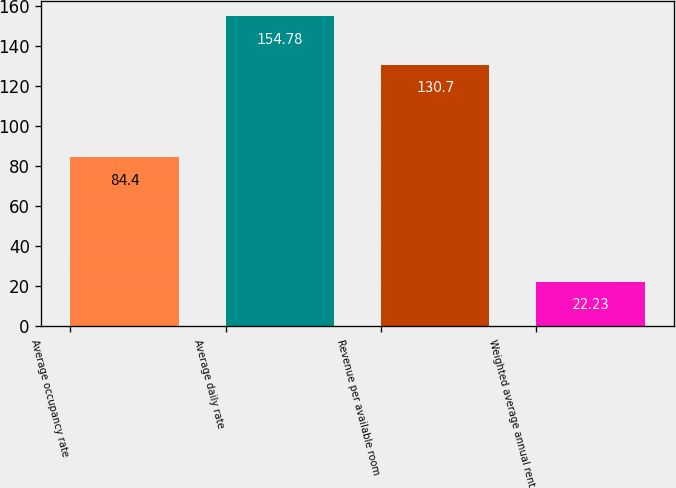Convert chart to OTSL. <chart><loc_0><loc_0><loc_500><loc_500><bar_chart><fcel>Average occupancy rate<fcel>Average daily rate<fcel>Revenue per available room<fcel>Weighted average annual rent<nl><fcel>84.4<fcel>154.78<fcel>130.7<fcel>22.23<nl></chart> 